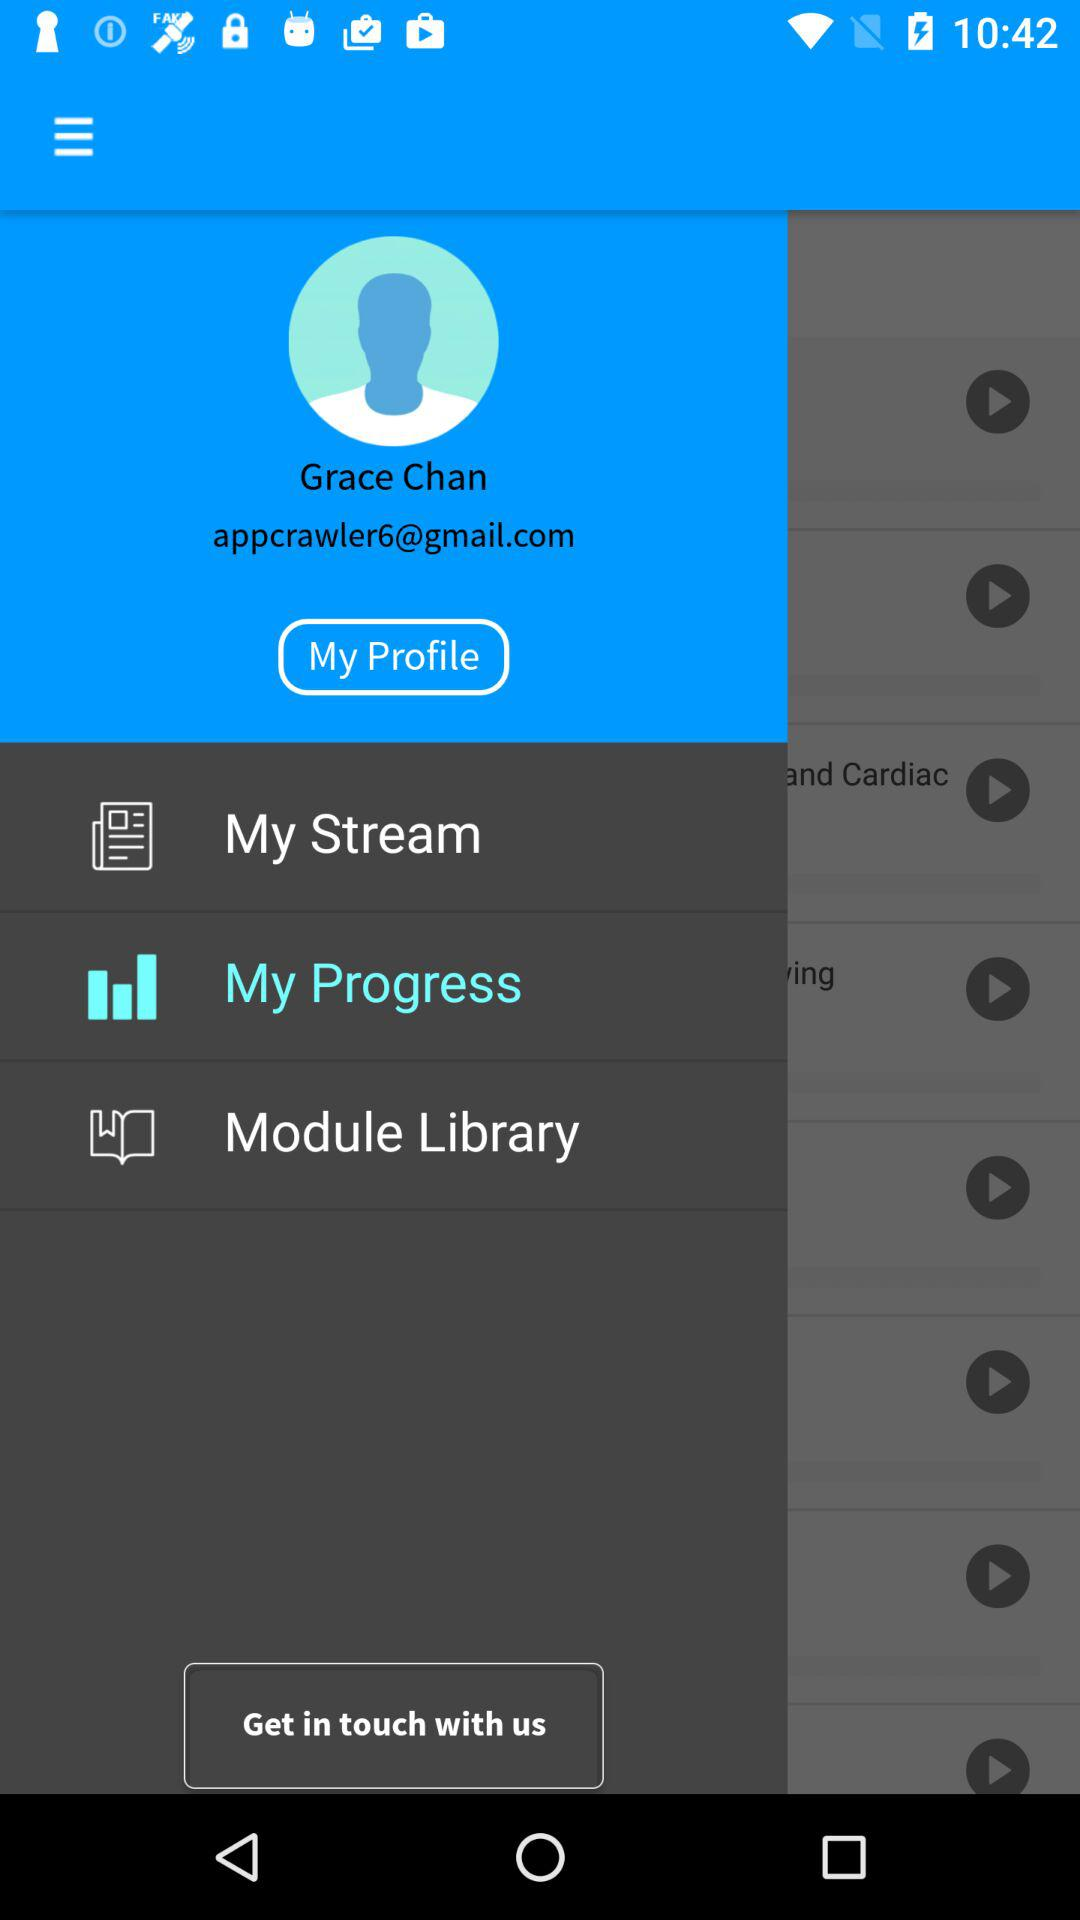How old is the user?
When the provided information is insufficient, respond with <no answer>. <no answer> 